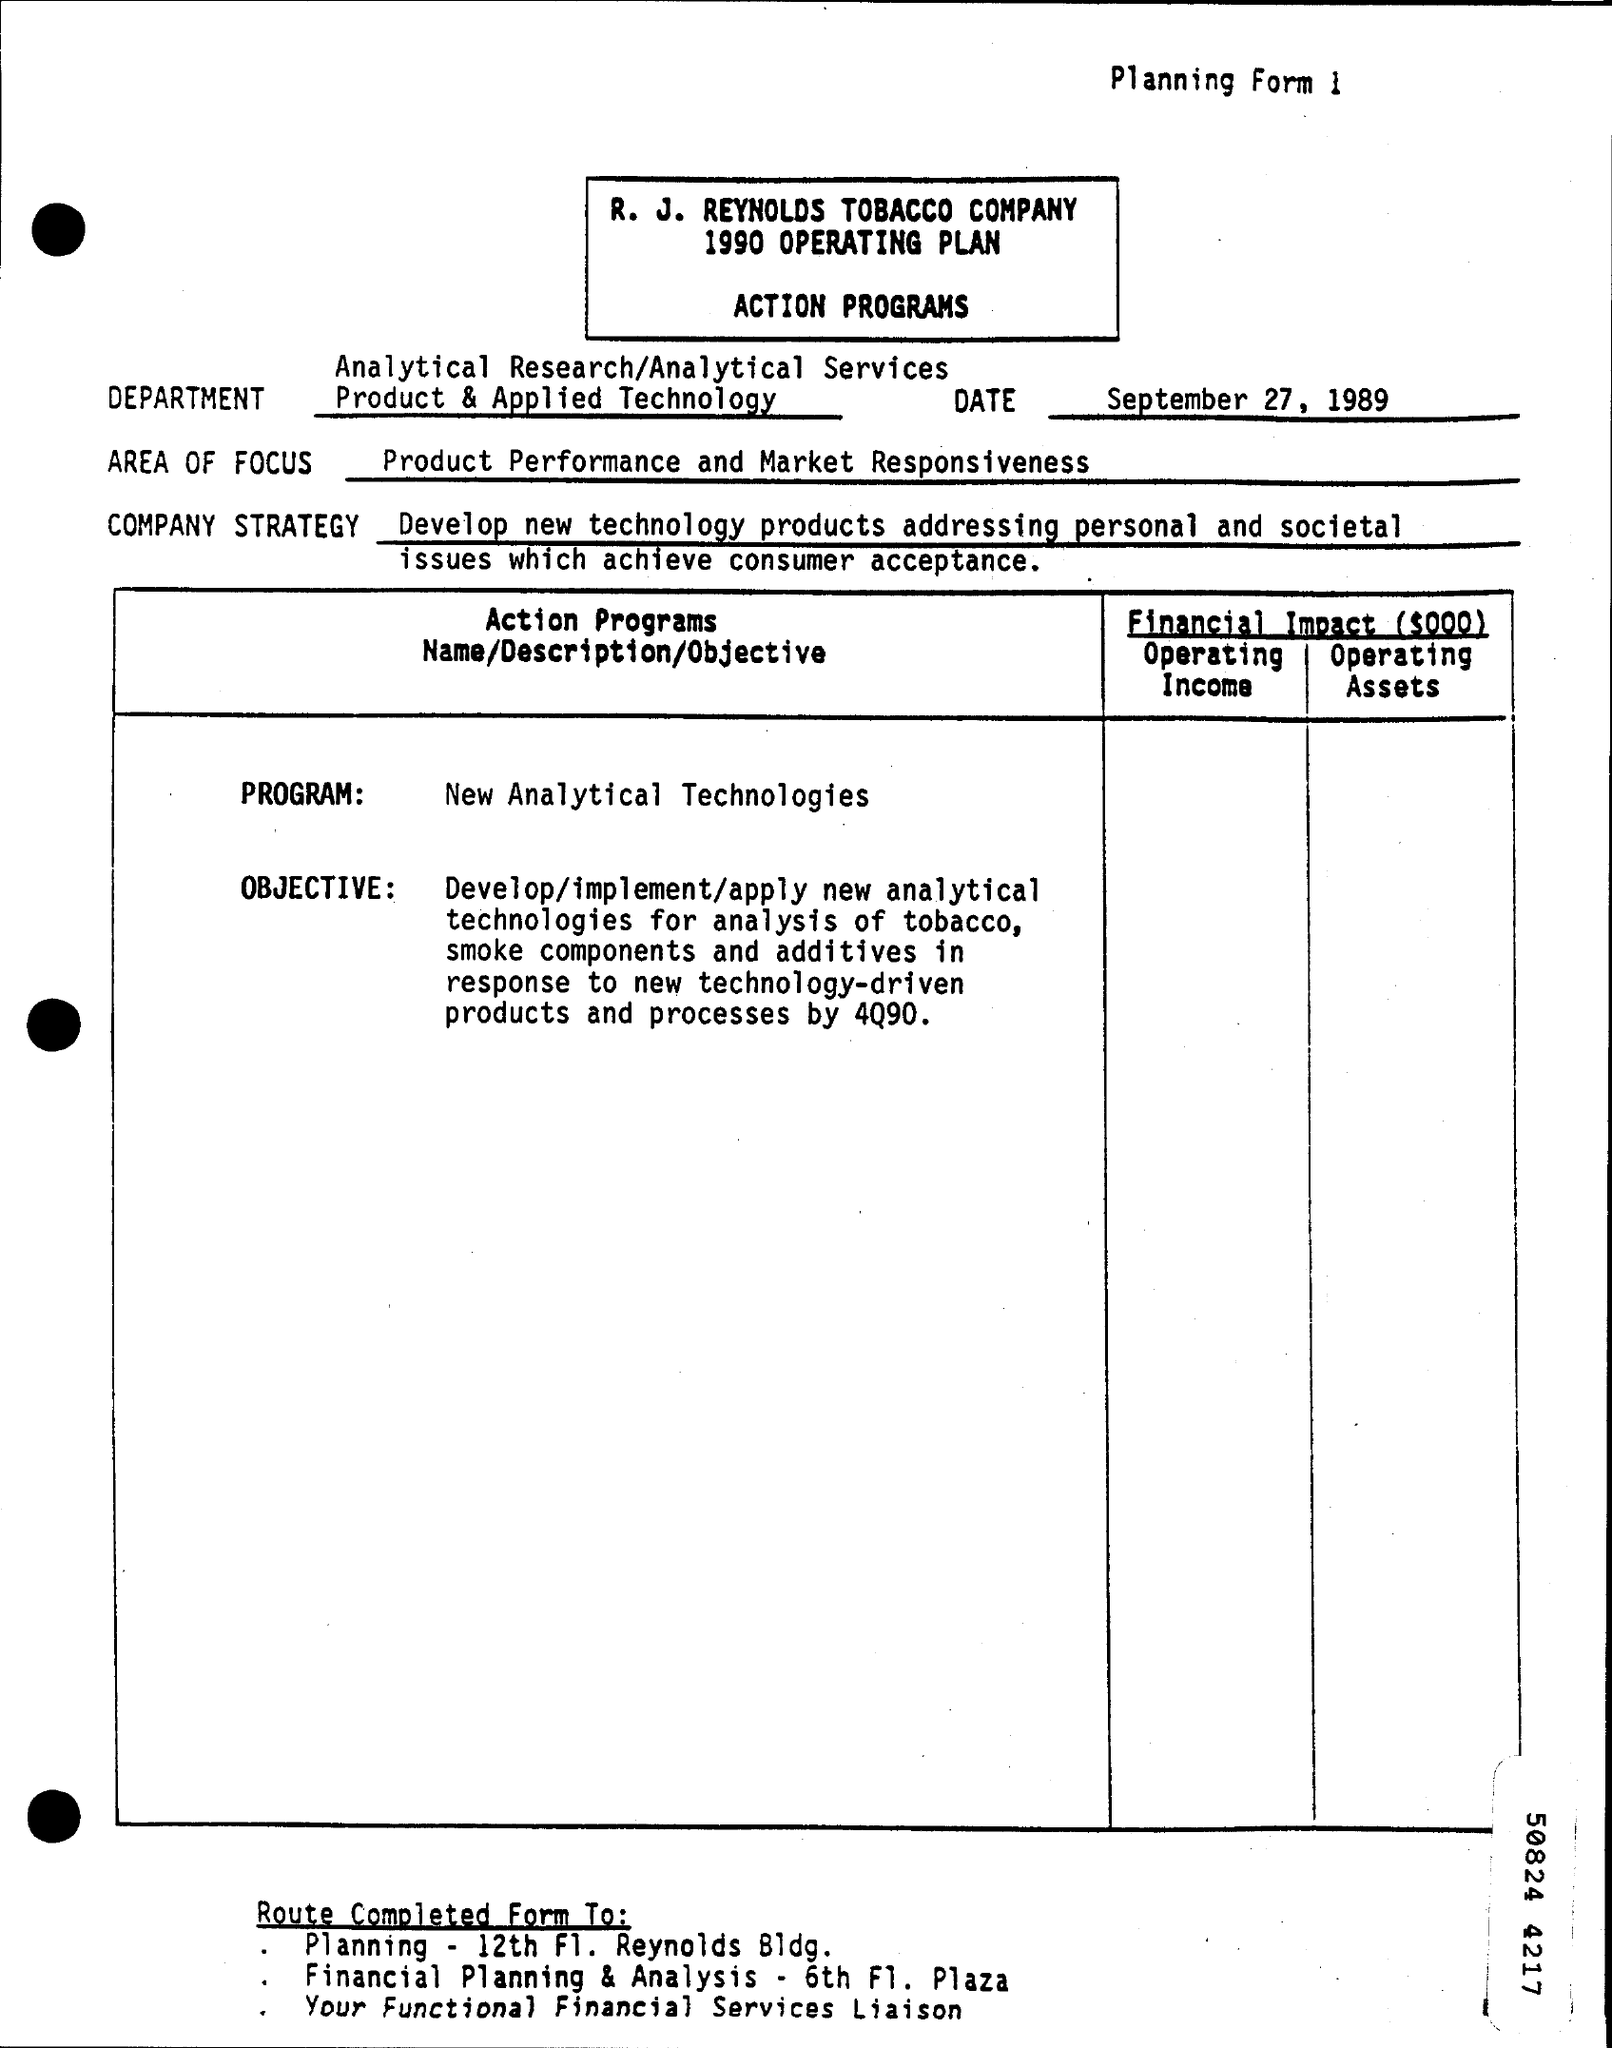What is the year of operating plan ?
Your answer should be very brief. 1990. What is the date on the form  ?
Make the answer very short. September 27, 1989. What is the area of focus ?
Keep it short and to the point. Product performance and market responsiveness. 